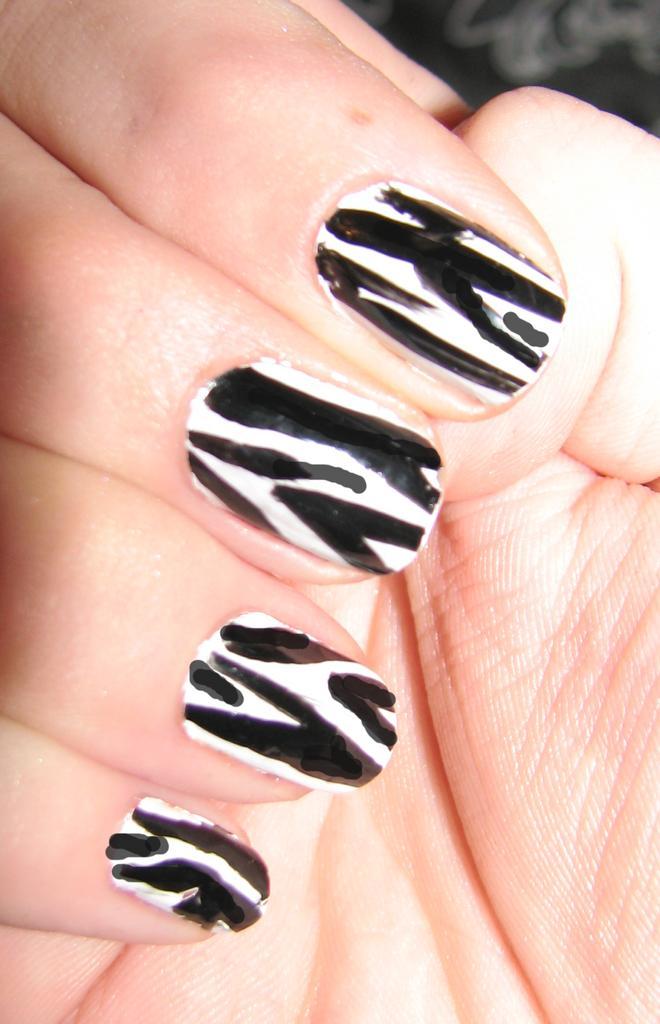Could you give a brief overview of what you see in this image? In this image in the foreground there is one person's hand is visible, and on the persons nails, there is nail paint. 